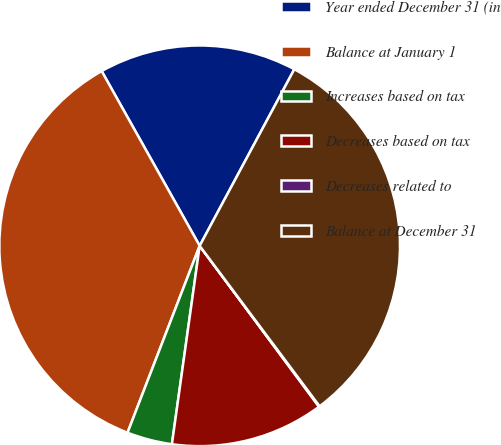Convert chart. <chart><loc_0><loc_0><loc_500><loc_500><pie_chart><fcel>Year ended December 31 (in<fcel>Balance at January 1<fcel>Increases based on tax<fcel>Decreases based on tax<fcel>Decreases related to<fcel>Balance at December 31<nl><fcel>15.97%<fcel>36.0%<fcel>3.65%<fcel>12.37%<fcel>0.06%<fcel>31.95%<nl></chart> 